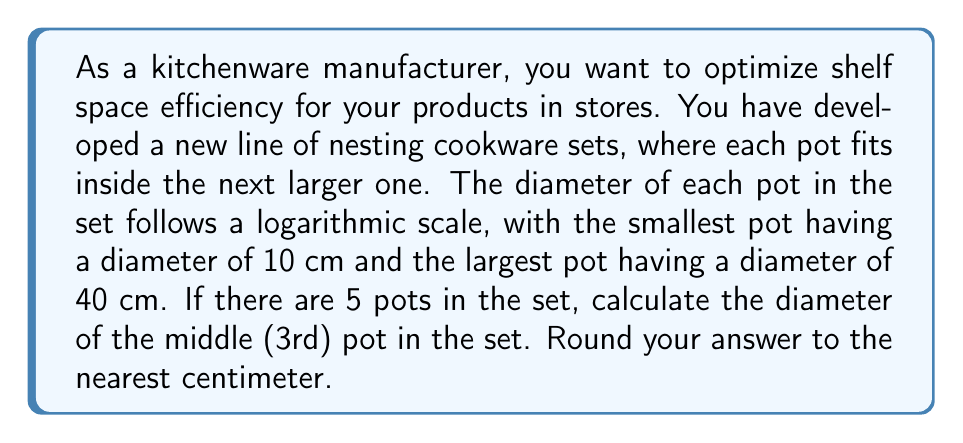Provide a solution to this math problem. To solve this problem, we'll use the properties of logarithmic scales:

1) First, we need to establish the logarithmic scale. Let's use the formula:
   $$d_n = d_1 \cdot a^{n-1}$$
   where $d_n$ is the diameter of the nth pot, $d_1$ is the diameter of the first pot, and $a$ is the common ratio.

2) We know:
   - $d_1 = 10$ cm (smallest pot)
   - $d_5 = 40$ cm (largest pot)
   - There are 5 pots in total

3) We can find the common ratio $a$ using:
   $$40 = 10 \cdot a^{5-1}$$
   $$4 = a^4$$
   $$a = \sqrt[4]{4} = 4^{1/4} \approx 1.4142$$

4) Now, to find the diameter of the 3rd pot, we use:
   $$d_3 = 10 \cdot (1.4142)^{3-1}$$
   $$d_3 = 10 \cdot (1.4142)^2$$
   $$d_3 = 10 \cdot 2$$
   $$d_3 = 20$$

5) Therefore, the diameter of the 3rd pot is 20 cm.

This logarithmic scale ensures that each pot is proportionally larger than the previous one, maximizing nesting efficiency and shelf space utilization.
Answer: 20 cm 